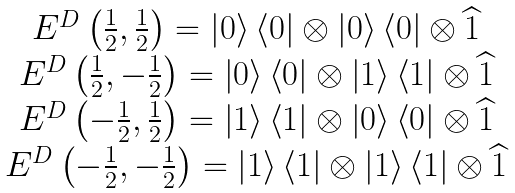<formula> <loc_0><loc_0><loc_500><loc_500>\begin{array} [ c ] { c } E ^ { D } \left ( \frac { 1 } { 2 } , \frac { 1 } { 2 } \right ) = \left | 0 \right \rangle \left \langle 0 \right | \otimes \left | 0 \right \rangle \left \langle 0 \right | \otimes \widehat { 1 } \\ E ^ { D } \left ( \frac { 1 } { 2 } , - \frac { 1 } { 2 } \right ) = \left | 0 \right \rangle \left \langle 0 \right | \otimes \left | 1 \right \rangle \left \langle 1 \right | \otimes \widehat { 1 } \\ E ^ { D } \left ( - \frac { 1 } { 2 } , \frac { 1 } { 2 } \right ) = \left | 1 \right \rangle \left \langle 1 \right | \otimes \left | 0 \right \rangle \left \langle 0 \right | \otimes \widehat { 1 } \\ E ^ { D } \left ( - \frac { 1 } { 2 } , - \frac { 1 } { 2 } \right ) = \left | 1 \right \rangle \left \langle 1 \right | \otimes \left | 1 \right \rangle \left \langle 1 \right | \otimes \widehat { 1 } \end{array}</formula> 